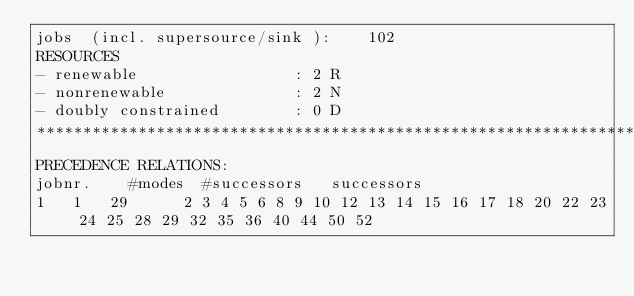Convert code to text. <code><loc_0><loc_0><loc_500><loc_500><_ObjectiveC_>jobs  (incl. supersource/sink ):	102
RESOURCES
- renewable                 : 2 R
- nonrenewable              : 2 N
- doubly constrained        : 0 D
************************************************************************
PRECEDENCE RELATIONS:
jobnr.    #modes  #successors   successors
1	1	29		2 3 4 5 6 8 9 10 12 13 14 15 16 17 18 20 22 23 24 25 28 29 32 35 36 40 44 50 52 </code> 